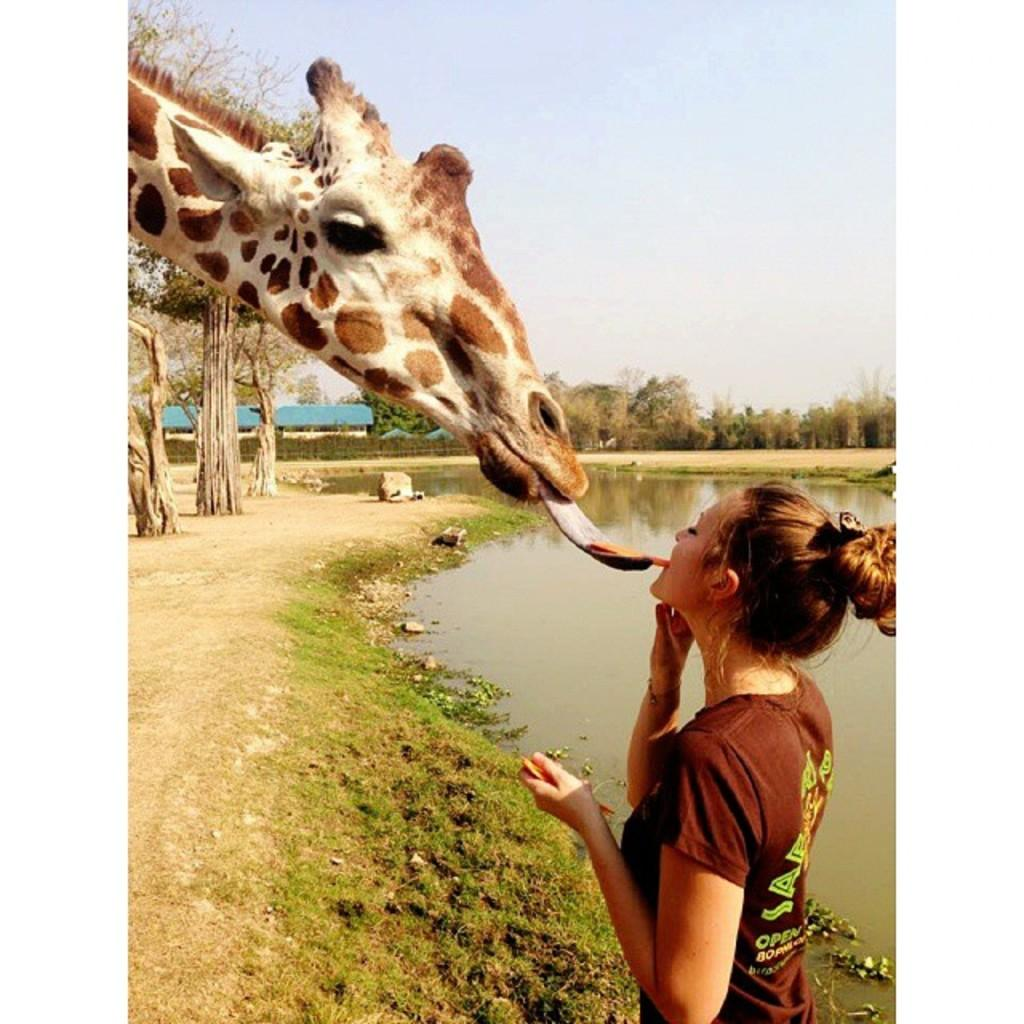What animal can be seen in the image? There is a giraffe in the image. What is the giraffe doing with its tongue? The giraffe's tongue is out in the image. Who else is present in the image besides the giraffe? There is a woman standing in the image. What can be seen in the background of the image? Water, trees, and a cloudy sky are visible in the image. What type of bridge can be seen in the image? There is no bridge present in the image. Can you describe the insect that is crawling on the giraffe's back? There is no insect visible on the giraffe's back in the image. 